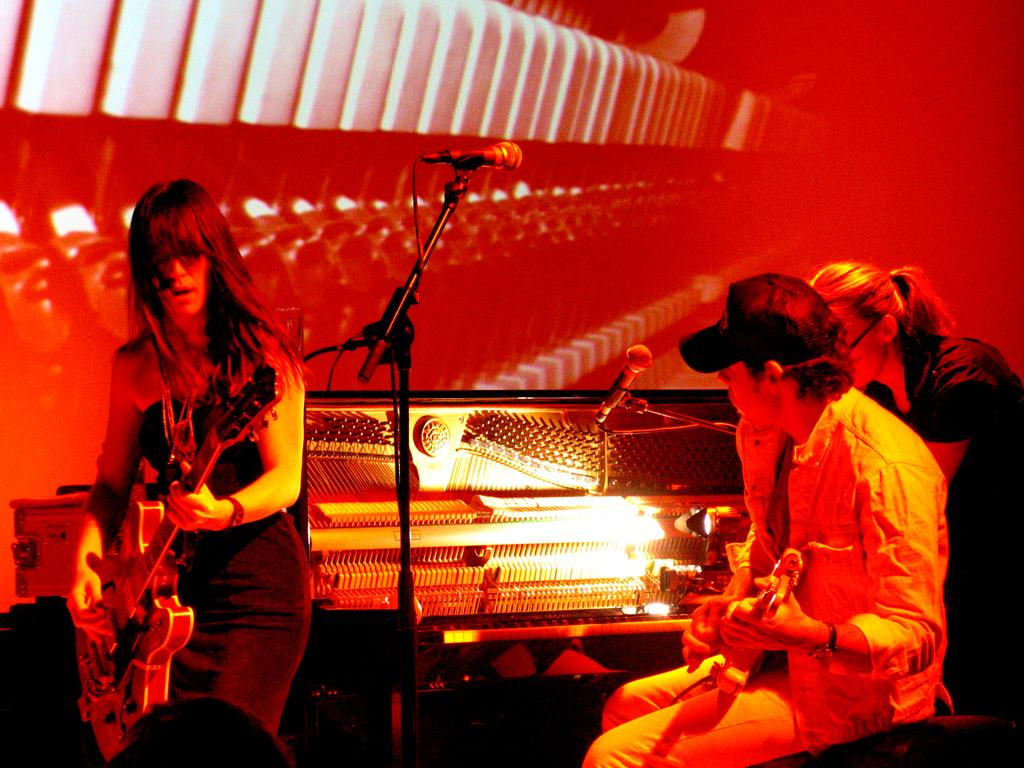What are the two people in the image doing? There is a woman playing a guitar and a man sitting and playing a guitar. What object is present for amplifying sound? There is a microphone with a holder in the image. What can be inferred about the setting based on the presence of musical instruments? The presence of musical instruments implies that the setting is related to music or a musical performance. How many times has the woman folded the guitar in the image? There is no indication in the image that the woman has folded the guitar, as guitars are not typically foldable. 